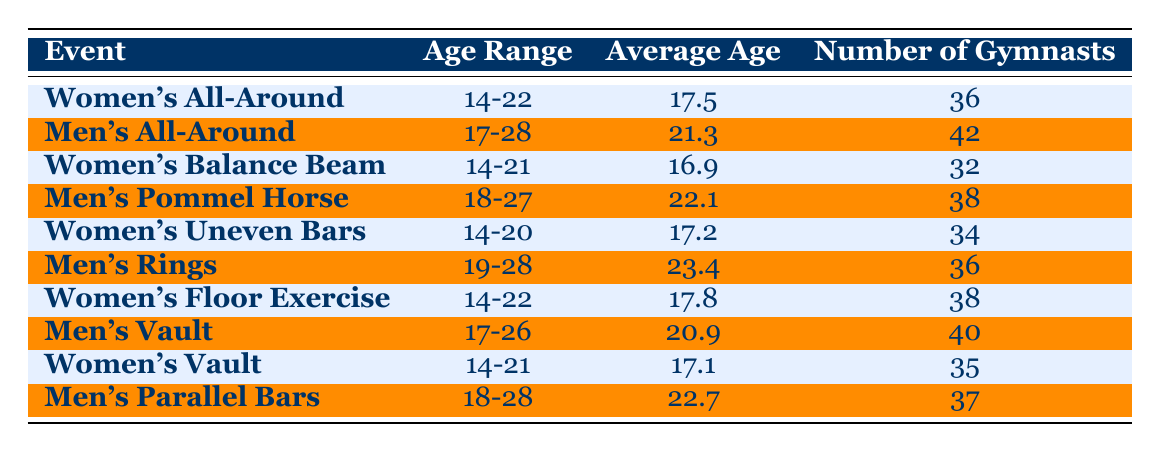What is the average age of gymnasts competing in the Women's All-Around event? The average age given in the table for the Women's All-Around event is 17.5. This value can be found directly under the "Average Age" column corresponding to the "Women's All-Around" event row.
Answer: 17.5 How many gymnasts competed in the Men's Rings event? The table shows that 36 gymnasts participated in the Men's Rings event, as indicated in the "Number of Gymnasts" column for that specific row.
Answer: 36 Is the age range for Men's Vault older than that of Women's Floor Exercise? The age range for Men's Vault is 17-26, while for Women's Floor Exercise it is 14-22. Since 17-26 starts at a higher minimum age than 14-22, the statement is true.
Answer: Yes What is the total number of gymnasts that participated in Women's events? To find the total, we add the number of gymnasts from all women's events: 36 (All-Around) + 32 (Balance Beam) + 34 (Uneven Bars) + 38 (Floor Exercise) + 35 (Vault) = 175. Thus, the total number of gymnasts in women's events is 175.
Answer: 175 What is the average age of gymnasts competing in all Men's events collectively? First, we need to calculate the average age for all Men's events. The ages are 21.3 (All-Around), 22.1 (Pommel Horse), 23.4 (Rings), 20.9 (Vault), and 22.7 (Parallel Bars). The sum of these averages is 110.4 and there are 5 events, so the average age is 110.4 / 5 = 22.08.
Answer: 22.08 Are there more gymnasts in the Men's All-Around compared to the Women's Uneven Bars? The table indicates that there are 42 gymnasts in the Men's All-Around and 34 in the Women's Uneven Bars. Since 42 is greater than 34, the statement is true.
Answer: Yes What is the difference in average age between the Men's Rings and Women's Balance Beam events? The average age for Men's Rings is 23.4, while for Women's Balance Beam it is 16.9. To find the difference, we subtract 16.9 from 23.4: 23.4 - 16.9 = 6.5.
Answer: 6.5 How many events have an average age of 22 or older? We can see from the table that the events with an average age of 22 or older are Men's All-Around (21.3), Men's Pommel Horse (22.1), Men's Rings (23.4), Men's Vault (20.9), and Men's Parallel Bars (22.7). Therefore, there are 4 events (Men's Pommel Horse, Men's Rings, Men's Vault, and Men's Parallel Bars) with an average age of 22 or older.
Answer: 4 What is the average age of gymnasts competing in Women's Vault? The average age for Women's Vault in the table is 17.1, which is found under the "Average Age" column next to the corresponding event.
Answer: 17.1 How many gymnasts competed in the Men's events combined? Summing the number of gymnasts from all Men's events: 42 (All-Around) + 38 (Pommel Horse) + 36 (Rings) + 40 (Vault) + 37 (Parallel Bars) = 193. Thus, the total number of gymnasts in Men's events combined is 193.
Answer: 193 